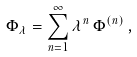<formula> <loc_0><loc_0><loc_500><loc_500>\Phi _ { \lambda } = \sum _ { n = 1 } ^ { \infty } \lambda ^ { n } \, \Phi ^ { ( n ) } \, ,</formula> 